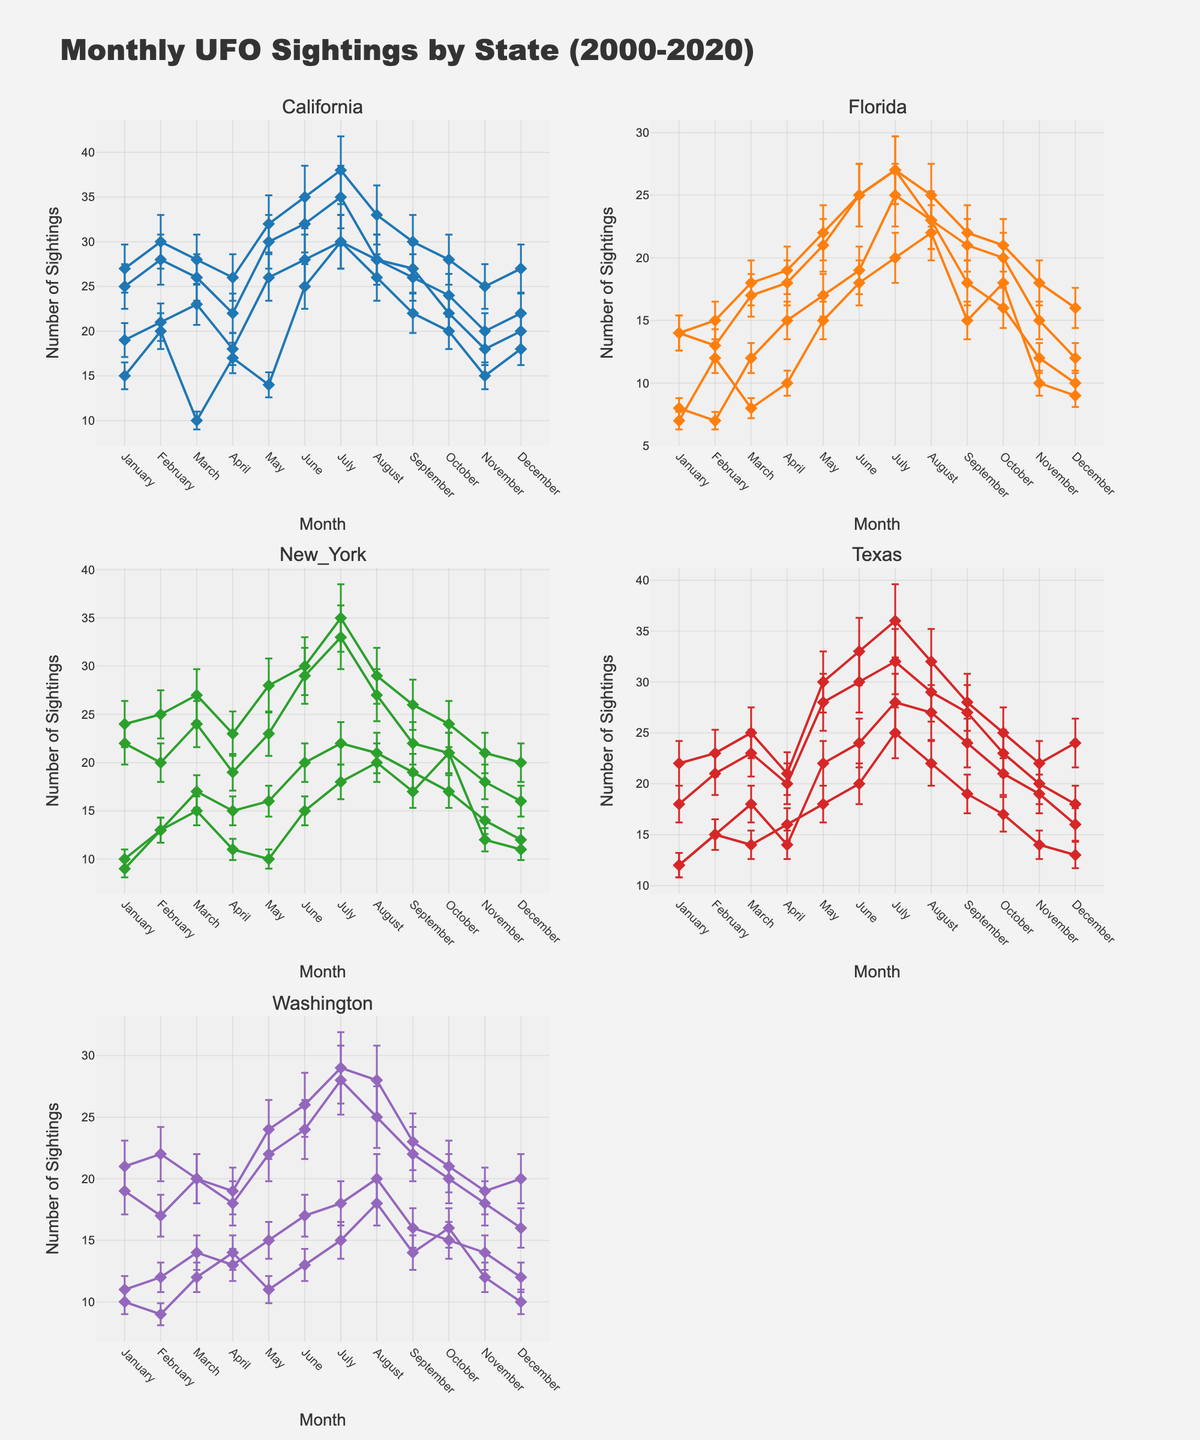What is the title of the figure? The title of the figure is centered at the top and is specified explicitly in the design.
Answer: Monthly UFO Sightings by State (2000-2020) How many states are displayed in the figure? The figure consists of subplots with one title for each state. Counting these titles gives the total number of states.
Answer: 5 Which state had the highest number of sightings in July 2020? Locate July 2020 on the x-axis for each state's subplot and compare the corresponding y-values. The highest y-value will indicate the state with the most sightings.
Answer: California What is the general trend of UFO sightings in California from January 2000 to July 2020? Observe the data points for California's subplot from the start (January 2000) to the latest available (July 2020) and describe the trend. This involves noting the increase or decrease over time.
Answer: Increasing How does the number of sightings in Texas compare in June 2019 and June 2020? Look at Texas's subplot, find June 2019 and June 2020, and compare the y-values for these points.
Answer: The number of sightings in Texas increased from June 2019 to June 2020 Which month and year had the maximum sightings in Florida, and what was the value? Examine the Florida subplot, find the highest data point, and note the coordinates (month and year) and the corresponding y-value.
Answer: July 2001, 25 sightings What is the average number of sightings in New York for the year 2020? Note the y-values for New York in 2020 across all months, sum them up, and divide by the number of months.
Answer: (24 + 25 + 27 + 23 + 28 + 30 + 35 + 29 + 26 + 24 + 21 + 20)/12 = 25.42 Which state shows the largest monthly variability in sightings, as indicated by the error bars? Assess the size and consistency of error bars in all subplots; the state with the largest and most frequent error bars indicates the highest variability.
Answer: California 